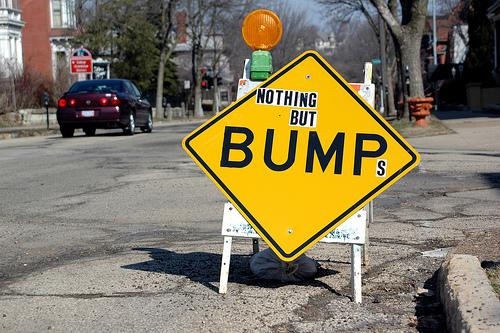Identify and briefly describe the main road sign in the image. The main road sign is a bright yellow and black street sign that says "Nothing But Bumps" and has an attached orange circular traffic light. Describe any cracks or damages observed on the road surface. There is a large crack in the paved road, visible in the lower portion of the image. Analyze the interactions between specific objects or components in the image, such as how an object relates to another object or setting. The shadow of the street sign falls on the ground, indicating the position of the sun or another light source, while the car drives near the yellow bump sign, indicating a possible reduction in speed due to caution. The concrete flower pots nearby suggest a possible attempt to beautify the area. Mention any noticeable aspects of the road or sidewalk, such as curbs or barriers. There is a white concrete curb by the sign and a raised cement curb on the lower right side of the image. What kind of sentiment or mood does the image evoke? The image evokes a sense of caution and awareness, due to the presence of the yellow bump sign and the crack on the road. How many vehicles are present in the picture? Describe their colors and positions. There is one maroon car visible in the picture, facing away from the camera and driving down the street. Identify the presence of any trees or plants in the image. There are no visible trees or plants in the image. Count the number of different signs found in the picture. There is only one visible sign in the image, which is the yellow bump sign. Determine the quality of the image by describing the clarity and detail of the objects within it. The image quality appears to be reasonably high, as the objects and features described, such as the sign, vehicle, and street elements, are all clear and detailed. Provide a brief description of the most notable objects seen in the image. The most notable objects in the image include a maroon car driving on the road and a yellow caution sign with the words "Nothing But Bumps" and an attached orange light. 